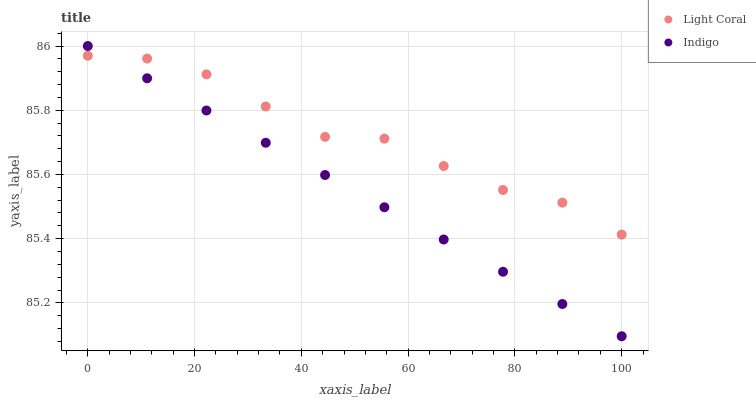Does Indigo have the minimum area under the curve?
Answer yes or no. Yes. Does Light Coral have the maximum area under the curve?
Answer yes or no. Yes. Does Indigo have the maximum area under the curve?
Answer yes or no. No. Is Indigo the smoothest?
Answer yes or no. Yes. Is Light Coral the roughest?
Answer yes or no. Yes. Is Indigo the roughest?
Answer yes or no. No. Does Indigo have the lowest value?
Answer yes or no. Yes. Does Indigo have the highest value?
Answer yes or no. Yes. Does Indigo intersect Light Coral?
Answer yes or no. Yes. Is Indigo less than Light Coral?
Answer yes or no. No. Is Indigo greater than Light Coral?
Answer yes or no. No. 